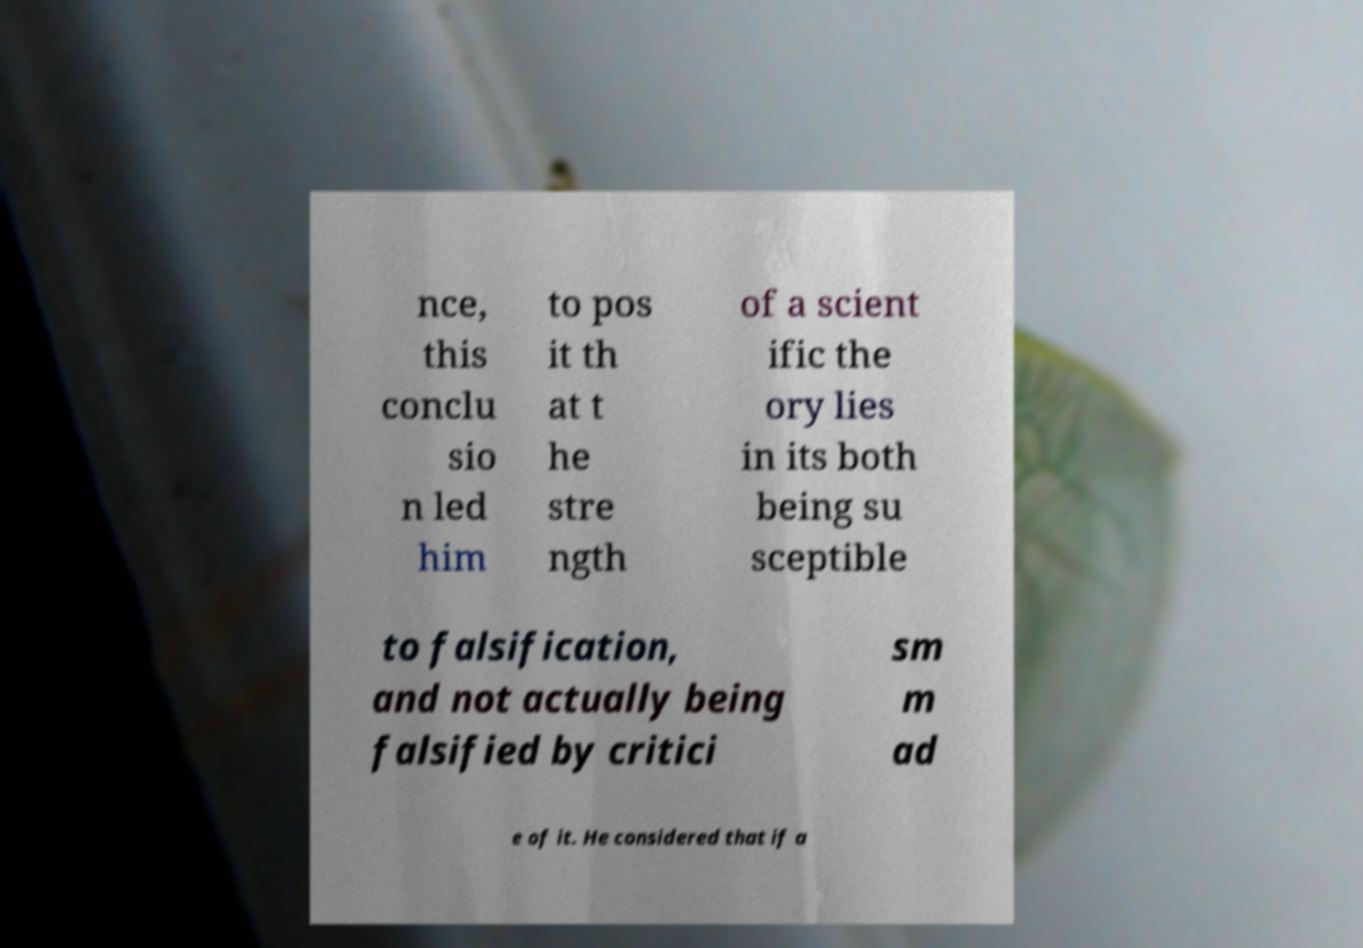Can you read and provide the text displayed in the image?This photo seems to have some interesting text. Can you extract and type it out for me? nce, this conclu sio n led him to pos it th at t he stre ngth of a scient ific the ory lies in its both being su sceptible to falsification, and not actually being falsified by critici sm m ad e of it. He considered that if a 